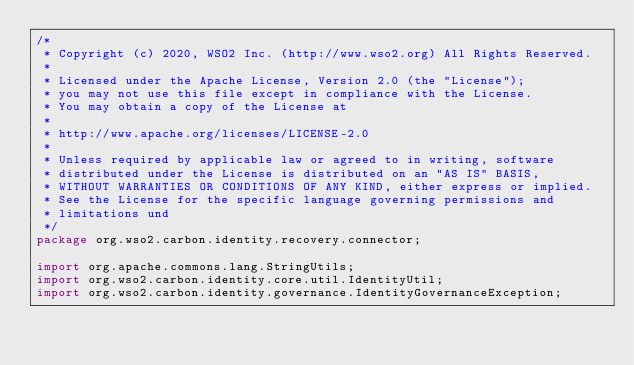Convert code to text. <code><loc_0><loc_0><loc_500><loc_500><_Java_>/*
 * Copyright (c) 2020, WSO2 Inc. (http://www.wso2.org) All Rights Reserved.
 *
 * Licensed under the Apache License, Version 2.0 (the "License");
 * you may not use this file except in compliance with the License.
 * You may obtain a copy of the License at
 *
 * http://www.apache.org/licenses/LICENSE-2.0
 *
 * Unless required by applicable law or agreed to in writing, software
 * distributed under the License is distributed on an "AS IS" BASIS,
 * WITHOUT WARRANTIES OR CONDITIONS OF ANY KIND, either express or implied.
 * See the License for the specific language governing permissions and
 * limitations und
 */
package org.wso2.carbon.identity.recovery.connector;

import org.apache.commons.lang.StringUtils;
import org.wso2.carbon.identity.core.util.IdentityUtil;
import org.wso2.carbon.identity.governance.IdentityGovernanceException;</code> 